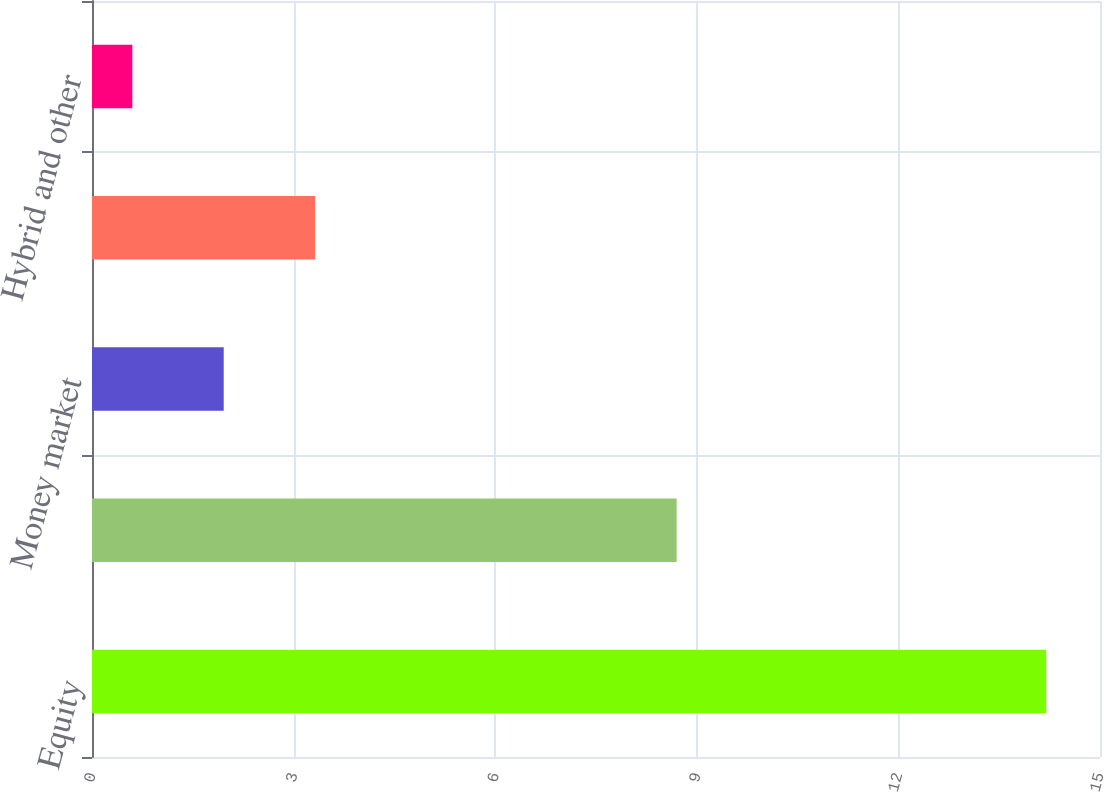Convert chart. <chart><loc_0><loc_0><loc_500><loc_500><bar_chart><fcel>Equity<fcel>Fixed income<fcel>Money market<fcel>Alternative<fcel>Hybrid and other<nl><fcel>14.2<fcel>8.7<fcel>1.96<fcel>3.32<fcel>0.6<nl></chart> 